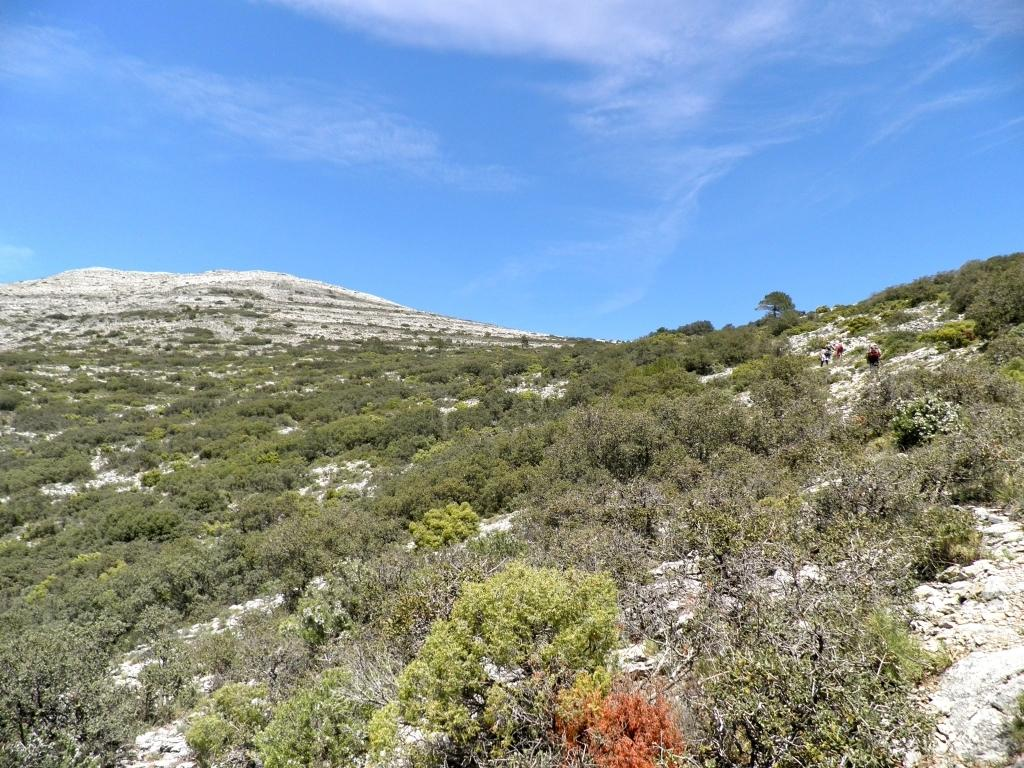What types of vegetation are present in the image? The image contains many plants and trees. What geographical feature is suggested by the scene in the image? The scene resembles a mountain. What is visible at the top of the image? The sky is visible at the top of the image. What type of engine can be seen powering the throne in the image? There is no engine or throne present in the image; it features plants, trees, and a mountainous scene. 